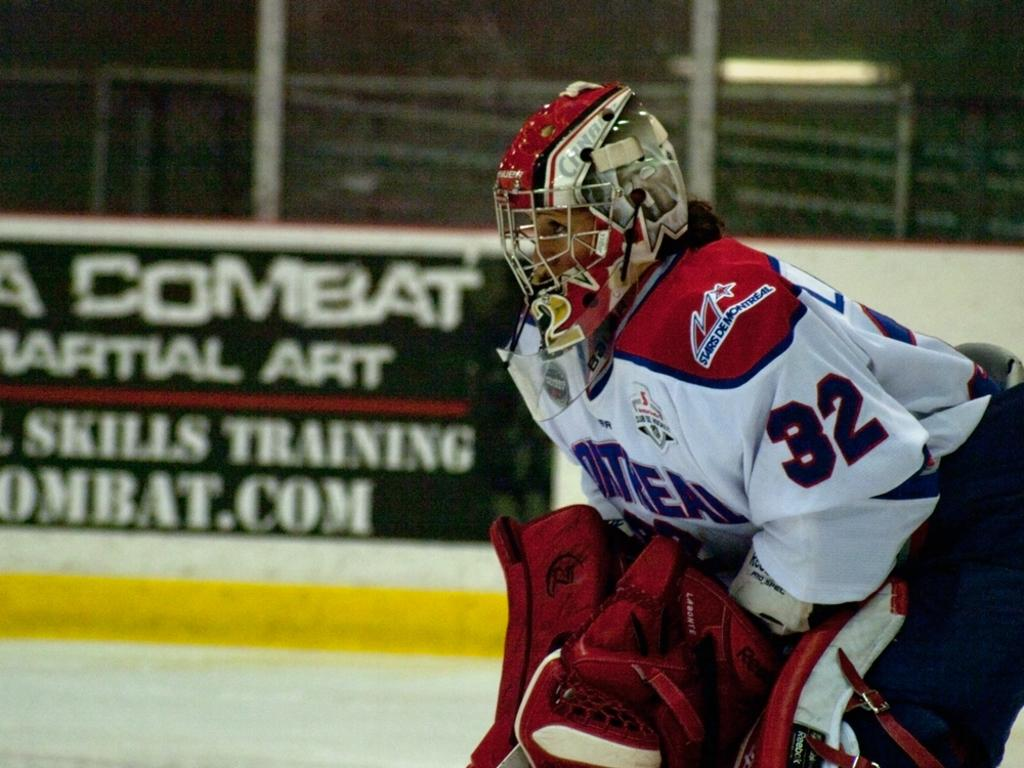What type of person is in the image? There is a sports person in the image. What protective gear is the sports person wearing? The sports person is wearing a helmet. What can be seen in the background of the image? There is a board and a fence in the background of the image. What type of story is the sports person telling in the image? There is no indication in the image that the sports person is telling a story, as the focus is on the sports person and their protective gear. 